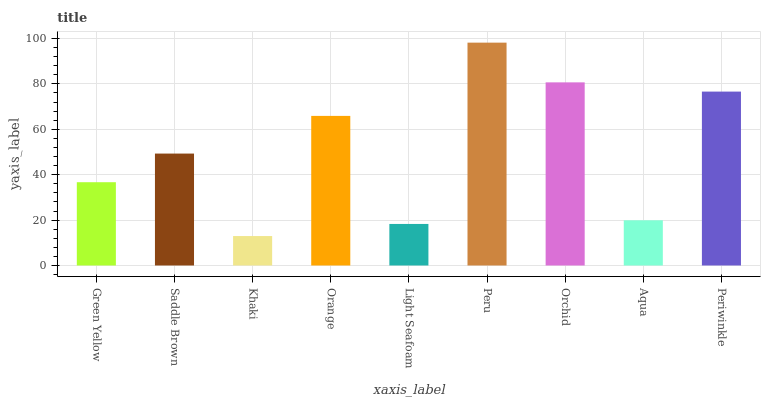Is Khaki the minimum?
Answer yes or no. Yes. Is Peru the maximum?
Answer yes or no. Yes. Is Saddle Brown the minimum?
Answer yes or no. No. Is Saddle Brown the maximum?
Answer yes or no. No. Is Saddle Brown greater than Green Yellow?
Answer yes or no. Yes. Is Green Yellow less than Saddle Brown?
Answer yes or no. Yes. Is Green Yellow greater than Saddle Brown?
Answer yes or no. No. Is Saddle Brown less than Green Yellow?
Answer yes or no. No. Is Saddle Brown the high median?
Answer yes or no. Yes. Is Saddle Brown the low median?
Answer yes or no. Yes. Is Khaki the high median?
Answer yes or no. No. Is Periwinkle the low median?
Answer yes or no. No. 